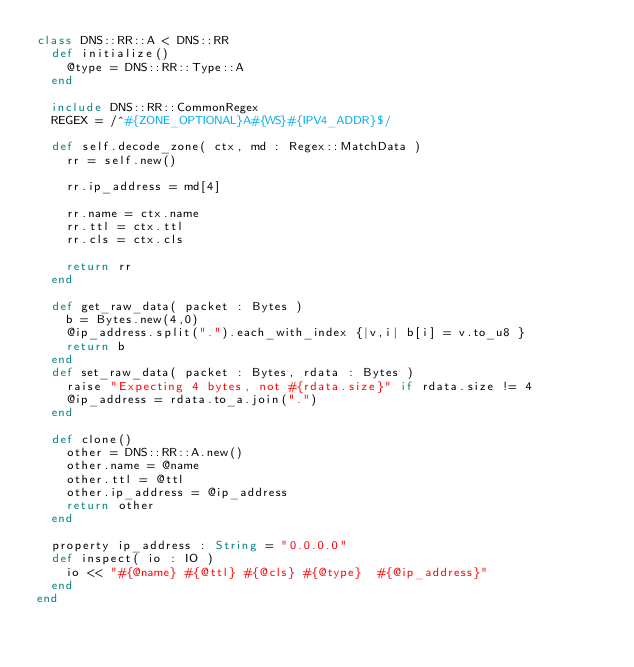<code> <loc_0><loc_0><loc_500><loc_500><_Crystal_>class DNS::RR::A < DNS::RR
	def initialize()
		@type = DNS::RR::Type::A
	end

	include DNS::RR::CommonRegex
	REGEX = /^#{ZONE_OPTIONAL}A#{WS}#{IPV4_ADDR}$/

	def self.decode_zone( ctx, md : Regex::MatchData )
		rr = self.new()
	
		rr.ip_address = md[4]

		rr.name = ctx.name
		rr.ttl = ctx.ttl
		rr.cls = ctx.cls

		return rr
	end

	def get_raw_data( packet : Bytes )
		b = Bytes.new(4,0)
		@ip_address.split(".").each_with_index {|v,i| b[i] = v.to_u8 }
		return b
	end
	def set_raw_data( packet : Bytes, rdata : Bytes )
		raise "Expecting 4 bytes, not #{rdata.size}" if rdata.size != 4
		@ip_address = rdata.to_a.join(".")
	end

	def clone()
		other = DNS::RR::A.new()
		other.name = @name
		other.ttl = @ttl
		other.ip_address = @ip_address
		return other
	end

	property ip_address : String = "0.0.0.0"
	def inspect( io : IO )
		io << "#{@name}	#{@ttl}	#{@cls}	#{@type}	#{@ip_address}"
	end
end

</code> 